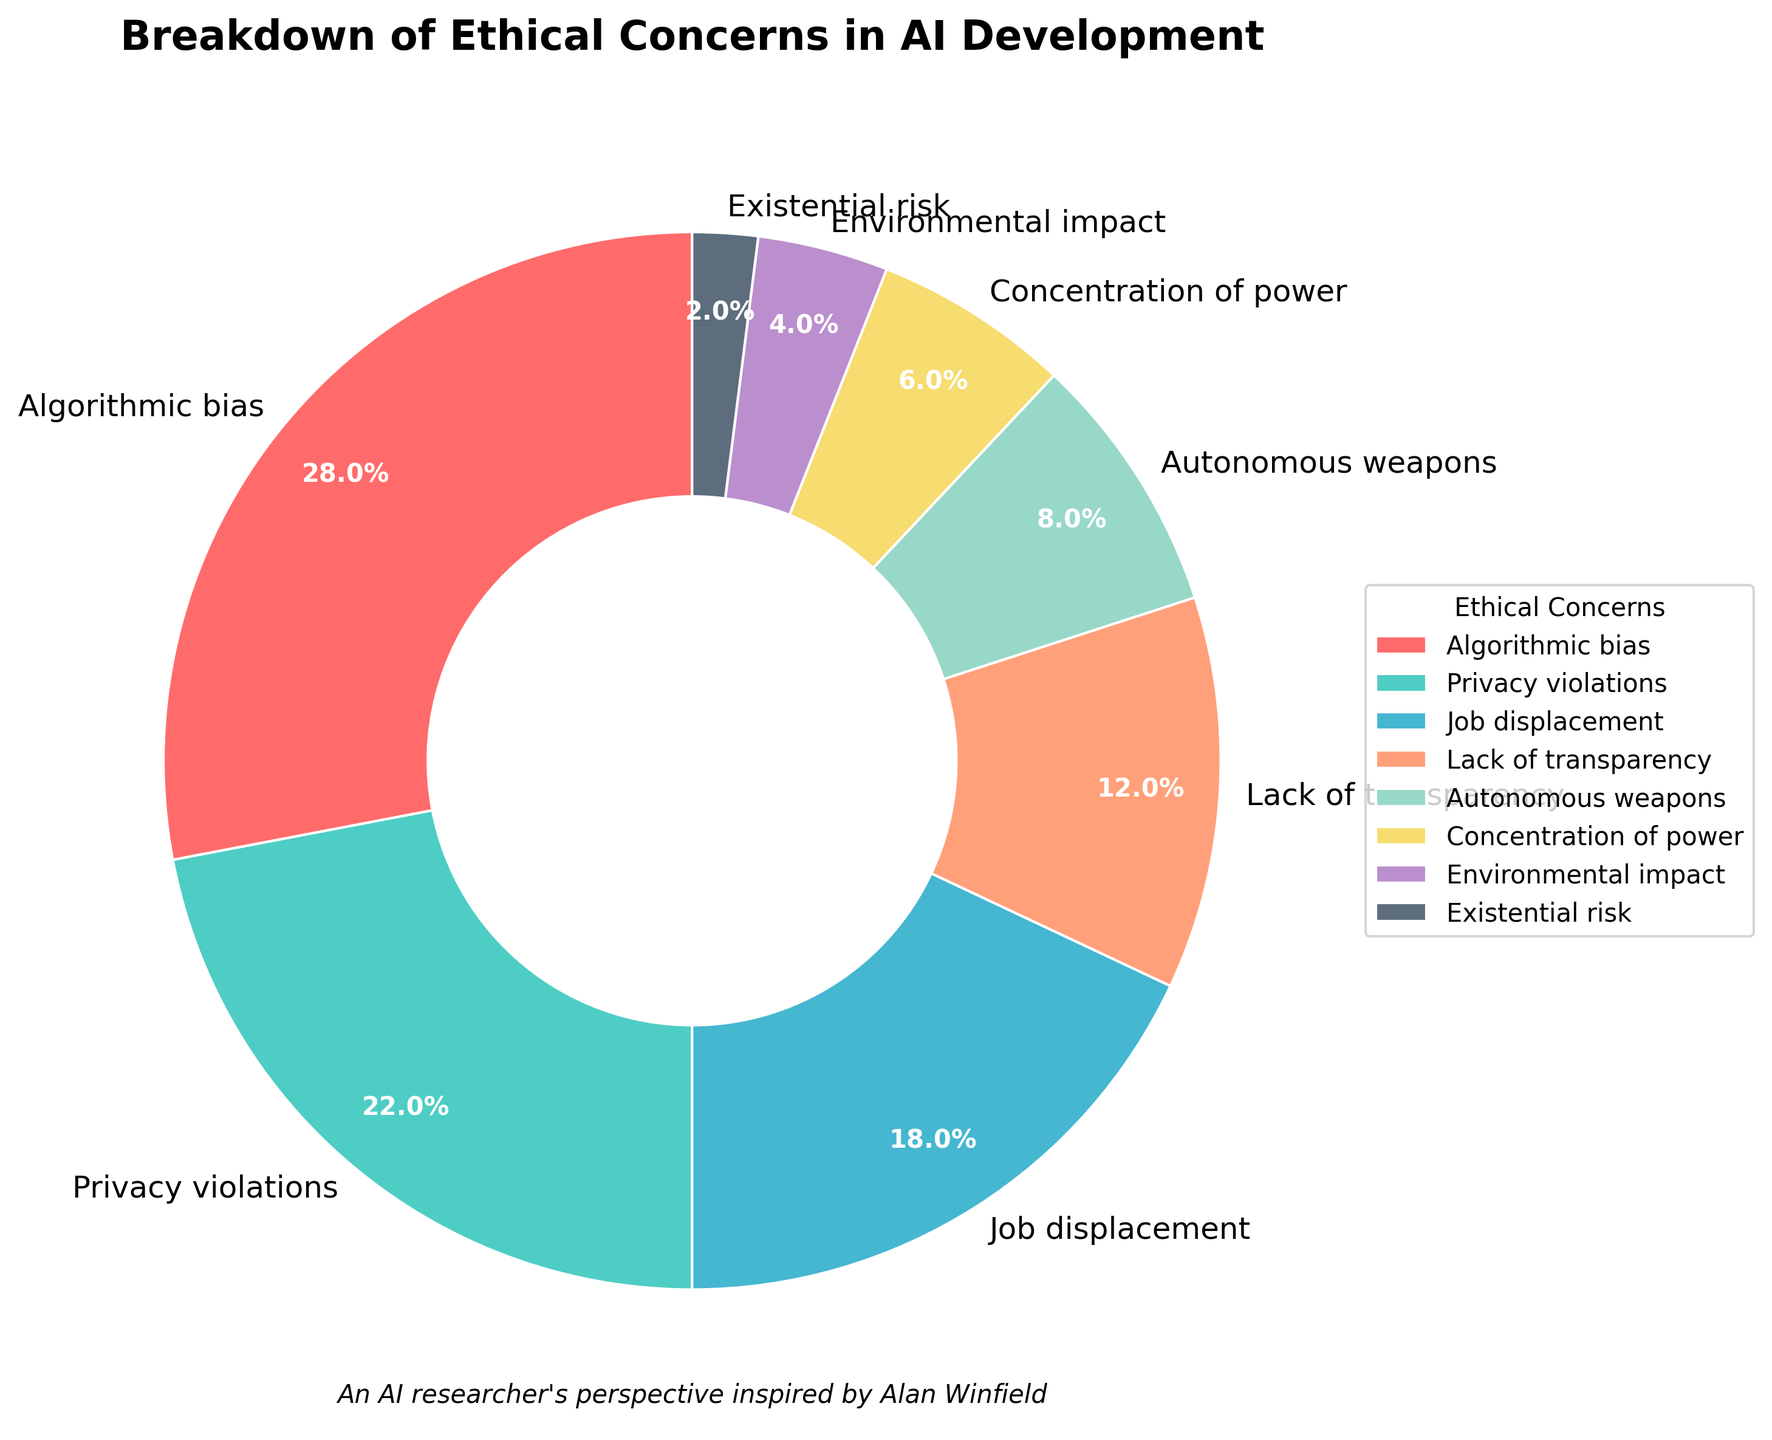What is the largest ethical concern in AI development according to the pie chart? The largest segment of the pie chart represents "Algorithmic bias" with a percentage of 28%, which is the highest among all concerns.
Answer: Algorithmic bias Which ethical concern has the smallest representation and what is its percentage? The smallest segment of the pie chart represents "Existential risk" with a percentage of 2%.
Answer: Existential risk, 2% What is the combined percentage of concerns related to Algorithmic bias and Privacy violations? "Algorithmic bias" is 28% and "Privacy violations" is 22%. Summing these two percentages: 28% + 22% = 50%
Answer: 50% How many ethical concerns have a percentage greater than 10%? From the pie chart, the concerns with more than 10% are "Algorithmic bias" (28%), "Privacy violations" (22%), and "Job displacement" (18%), and "Lack of transparency" (12%). This makes four concerns in total.
Answer: 4 Is the percentage for Environmental impact larger or smaller than that for Autonomous weapons? "Environmental impact" is 4% while "Autonomous weapons" is 8%. Comparing the two percentages, 4% is smaller than 8%.
Answer: Smaller Which concern depicted in red has what percentage? The concern depicted in red is "Algorithmic bias" and it has a percentage of 28%.
Answer: Algorithmic bias, 28% What is the average percentage of the top three ethical concerns? The top three concerns are "Algorithmic bias" (28%), "Privacy violations" (22%), and "Job displacement" (18%). The average percentage is calculated as: (28% + 22% + 18%) / 3 = 22.67%
Answer: 22.67% Are there more concerns with a percentage of 10% or higher, or below 10%? The concerns with a percentage of 10% or higher are "Algorithmic bias" (28%), "Privacy violations" (22%), "Job displacement" (18%), and "Lack of transparency" (12%) making a total of 4. Those below 10% are "Autonomous weapons" (8%), "Concentration of power" (6%), "Environmental impact" (4%), and "Existential risk" (2%), also making a total of 4. As there is an equal number of each, the answer is none.
Answer: None 